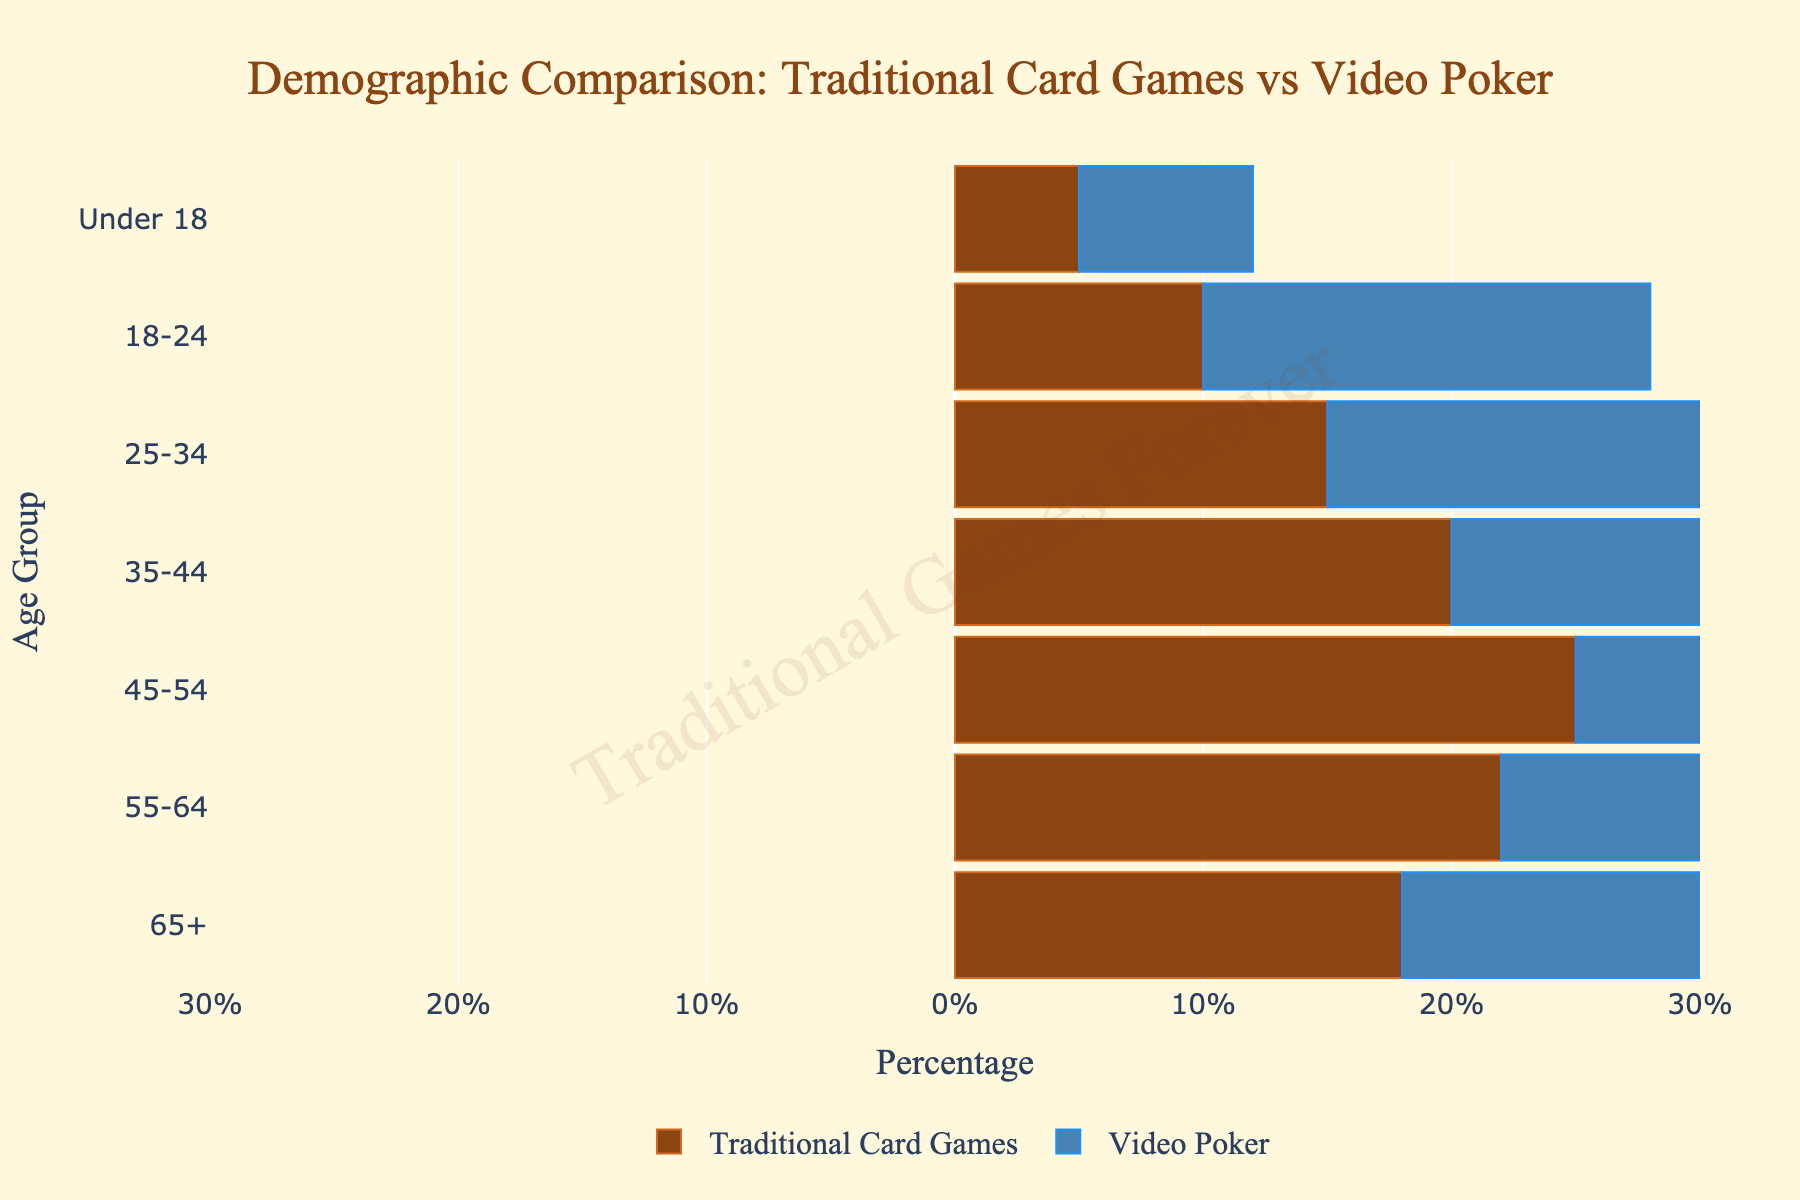What's the title of the figure? At the top of the figure, there is a text indicating the purpose and focus of the comparison between two demographics.
Answer: Demographic Comparison: Traditional Card Games vs Video Poker What does the color blue represent in the figure? The color blue is associated with the data on the right side of the pyramid, which indicates the proportion of Video Poker players across different age groups.
Answer: Video Poker Which age group has the highest percentage of Traditional Card Games enthusiasts? Looking at the series of bars labeled for Traditional Card Games, the bar with the highest length corresponds to the age group 45-54.
Answer: 45-54 What is the percentage of Video Poker players in the 35-44 age group? The figure includes percentage labels for each bar. For Video Poker in the 35-44 age group, the bar extends to a value on the negative part of the axis.
Answer: 28% How are the age groups distributed along the y-axis? The y-axis lists the various age groups from younger to older, with the Under 18 group at the bottom and the 65+ group at the top.
Answer: From Under 18 at the bottom to 65+ at the top Which age group shows a larger gap between Traditional Card Games and Video Poker enthusiasts? The gap can be determined by comparing the lengths of the bars for each age group. The 35-44 age group shows the most significant difference with Traditional Card Games at 20% and Video Poker at 28%.
Answer: 35-44 What is the total percentage of all Traditional Card Games enthusiasts aged 25 and above? Sum the percentages of the age groups 25-34, 35-44, 45-54, 55-64, and 65+ for Traditional Card Games (15% + 20% + 25% + 22% + 18%). The total is 100%.
Answer: 100% Which age group has a nearly equal percentage of Traditional Card Games and Video Poker enthusiasts? By looking at the bars that have nearly the same length, the 18-24 age group shows a small difference between Traditional Card Games (10%) and Video Poker (18%).
Answer: None, as 18-24 still has a noticeable difference What is the age group with the lowest percentage of Traditional Card Game enthusiasts? Check the series of bars for Traditional Card Games and find the one with the smallest length. The lowest percentage is in the Under 18 age group.
Answer: Under 18 How does the percentage of Video Poker players compare to Traditional Card Games enthusiasts in the 55-64 age group? Compare the bars for the 55-64 age group. Traditional Card Games enthusiasts are at 22%, and Video Poker players are at 15%. The former is higher.
Answer: Traditional Card Games is higher 